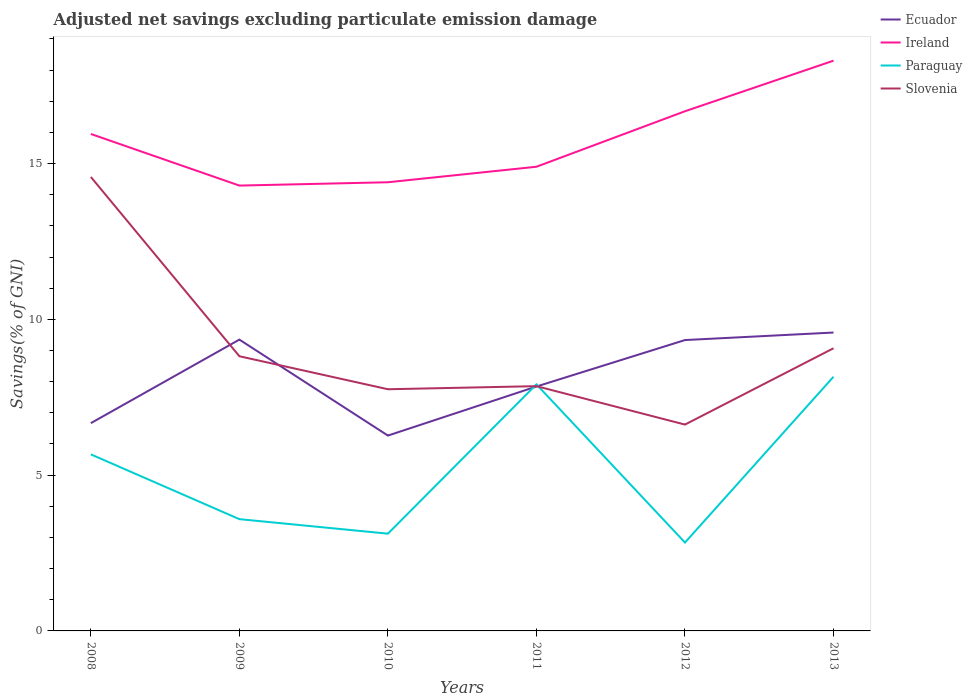How many different coloured lines are there?
Give a very brief answer. 4. Does the line corresponding to Slovenia intersect with the line corresponding to Ireland?
Make the answer very short. No. Is the number of lines equal to the number of legend labels?
Provide a succinct answer. Yes. Across all years, what is the maximum adjusted net savings in Slovenia?
Provide a succinct answer. 6.62. In which year was the adjusted net savings in Slovenia maximum?
Your response must be concise. 2012. What is the total adjusted net savings in Paraguay in the graph?
Make the answer very short. -2.25. What is the difference between the highest and the second highest adjusted net savings in Paraguay?
Your response must be concise. 5.32. Is the adjusted net savings in Ireland strictly greater than the adjusted net savings in Ecuador over the years?
Provide a succinct answer. No. How many lines are there?
Ensure brevity in your answer.  4. Are the values on the major ticks of Y-axis written in scientific E-notation?
Your response must be concise. No. Does the graph contain any zero values?
Ensure brevity in your answer.  No. Does the graph contain grids?
Provide a succinct answer. No. What is the title of the graph?
Ensure brevity in your answer.  Adjusted net savings excluding particulate emission damage. What is the label or title of the Y-axis?
Ensure brevity in your answer.  Savings(% of GNI). What is the Savings(% of GNI) in Ecuador in 2008?
Provide a succinct answer. 6.67. What is the Savings(% of GNI) in Ireland in 2008?
Make the answer very short. 15.95. What is the Savings(% of GNI) of Paraguay in 2008?
Offer a terse response. 5.67. What is the Savings(% of GNI) of Slovenia in 2008?
Make the answer very short. 14.57. What is the Savings(% of GNI) of Ecuador in 2009?
Ensure brevity in your answer.  9.35. What is the Savings(% of GNI) of Ireland in 2009?
Give a very brief answer. 14.29. What is the Savings(% of GNI) in Paraguay in 2009?
Your answer should be compact. 3.59. What is the Savings(% of GNI) of Slovenia in 2009?
Your answer should be very brief. 8.82. What is the Savings(% of GNI) in Ecuador in 2010?
Offer a very short reply. 6.27. What is the Savings(% of GNI) of Ireland in 2010?
Your answer should be very brief. 14.4. What is the Savings(% of GNI) of Paraguay in 2010?
Offer a terse response. 3.12. What is the Savings(% of GNI) in Slovenia in 2010?
Provide a succinct answer. 7.76. What is the Savings(% of GNI) of Ecuador in 2011?
Keep it short and to the point. 7.84. What is the Savings(% of GNI) of Ireland in 2011?
Your answer should be compact. 14.9. What is the Savings(% of GNI) in Paraguay in 2011?
Ensure brevity in your answer.  7.91. What is the Savings(% of GNI) in Slovenia in 2011?
Keep it short and to the point. 7.86. What is the Savings(% of GNI) in Ecuador in 2012?
Offer a terse response. 9.34. What is the Savings(% of GNI) in Ireland in 2012?
Your response must be concise. 16.68. What is the Savings(% of GNI) of Paraguay in 2012?
Your answer should be very brief. 2.84. What is the Savings(% of GNI) in Slovenia in 2012?
Make the answer very short. 6.62. What is the Savings(% of GNI) in Ecuador in 2013?
Give a very brief answer. 9.58. What is the Savings(% of GNI) in Ireland in 2013?
Offer a terse response. 18.3. What is the Savings(% of GNI) of Paraguay in 2013?
Your response must be concise. 8.16. What is the Savings(% of GNI) of Slovenia in 2013?
Your answer should be very brief. 9.07. Across all years, what is the maximum Savings(% of GNI) in Ecuador?
Provide a short and direct response. 9.58. Across all years, what is the maximum Savings(% of GNI) of Ireland?
Your response must be concise. 18.3. Across all years, what is the maximum Savings(% of GNI) in Paraguay?
Provide a short and direct response. 8.16. Across all years, what is the maximum Savings(% of GNI) of Slovenia?
Make the answer very short. 14.57. Across all years, what is the minimum Savings(% of GNI) of Ecuador?
Offer a terse response. 6.27. Across all years, what is the minimum Savings(% of GNI) of Ireland?
Keep it short and to the point. 14.29. Across all years, what is the minimum Savings(% of GNI) of Paraguay?
Your response must be concise. 2.84. Across all years, what is the minimum Savings(% of GNI) of Slovenia?
Provide a succinct answer. 6.62. What is the total Savings(% of GNI) in Ecuador in the graph?
Offer a terse response. 49.05. What is the total Savings(% of GNI) of Ireland in the graph?
Keep it short and to the point. 94.53. What is the total Savings(% of GNI) of Paraguay in the graph?
Offer a terse response. 31.29. What is the total Savings(% of GNI) of Slovenia in the graph?
Provide a short and direct response. 54.7. What is the difference between the Savings(% of GNI) of Ecuador in 2008 and that in 2009?
Offer a very short reply. -2.68. What is the difference between the Savings(% of GNI) in Ireland in 2008 and that in 2009?
Keep it short and to the point. 1.66. What is the difference between the Savings(% of GNI) of Paraguay in 2008 and that in 2009?
Keep it short and to the point. 2.08. What is the difference between the Savings(% of GNI) in Slovenia in 2008 and that in 2009?
Provide a short and direct response. 5.75. What is the difference between the Savings(% of GNI) in Ecuador in 2008 and that in 2010?
Ensure brevity in your answer.  0.4. What is the difference between the Savings(% of GNI) in Ireland in 2008 and that in 2010?
Provide a succinct answer. 1.55. What is the difference between the Savings(% of GNI) of Paraguay in 2008 and that in 2010?
Your answer should be compact. 2.55. What is the difference between the Savings(% of GNI) in Slovenia in 2008 and that in 2010?
Ensure brevity in your answer.  6.81. What is the difference between the Savings(% of GNI) in Ecuador in 2008 and that in 2011?
Your answer should be very brief. -1.18. What is the difference between the Savings(% of GNI) in Ireland in 2008 and that in 2011?
Offer a very short reply. 1.05. What is the difference between the Savings(% of GNI) of Paraguay in 2008 and that in 2011?
Your answer should be compact. -2.25. What is the difference between the Savings(% of GNI) of Slovenia in 2008 and that in 2011?
Give a very brief answer. 6.71. What is the difference between the Savings(% of GNI) of Ecuador in 2008 and that in 2012?
Offer a terse response. -2.67. What is the difference between the Savings(% of GNI) in Ireland in 2008 and that in 2012?
Your answer should be very brief. -0.73. What is the difference between the Savings(% of GNI) of Paraguay in 2008 and that in 2012?
Your answer should be very brief. 2.83. What is the difference between the Savings(% of GNI) in Slovenia in 2008 and that in 2012?
Offer a very short reply. 7.95. What is the difference between the Savings(% of GNI) in Ecuador in 2008 and that in 2013?
Provide a succinct answer. -2.91. What is the difference between the Savings(% of GNI) in Ireland in 2008 and that in 2013?
Your answer should be compact. -2.35. What is the difference between the Savings(% of GNI) in Paraguay in 2008 and that in 2013?
Ensure brevity in your answer.  -2.49. What is the difference between the Savings(% of GNI) of Slovenia in 2008 and that in 2013?
Your response must be concise. 5.5. What is the difference between the Savings(% of GNI) of Ecuador in 2009 and that in 2010?
Give a very brief answer. 3.08. What is the difference between the Savings(% of GNI) in Ireland in 2009 and that in 2010?
Your answer should be compact. -0.11. What is the difference between the Savings(% of GNI) of Paraguay in 2009 and that in 2010?
Give a very brief answer. 0.47. What is the difference between the Savings(% of GNI) in Slovenia in 2009 and that in 2010?
Ensure brevity in your answer.  1.06. What is the difference between the Savings(% of GNI) of Ecuador in 2009 and that in 2011?
Offer a terse response. 1.51. What is the difference between the Savings(% of GNI) of Ireland in 2009 and that in 2011?
Ensure brevity in your answer.  -0.6. What is the difference between the Savings(% of GNI) of Paraguay in 2009 and that in 2011?
Make the answer very short. -4.33. What is the difference between the Savings(% of GNI) in Slovenia in 2009 and that in 2011?
Offer a terse response. 0.96. What is the difference between the Savings(% of GNI) of Ecuador in 2009 and that in 2012?
Offer a very short reply. 0.01. What is the difference between the Savings(% of GNI) of Ireland in 2009 and that in 2012?
Your answer should be compact. -2.39. What is the difference between the Savings(% of GNI) in Paraguay in 2009 and that in 2012?
Your answer should be compact. 0.75. What is the difference between the Savings(% of GNI) of Slovenia in 2009 and that in 2012?
Your answer should be compact. 2.19. What is the difference between the Savings(% of GNI) in Ecuador in 2009 and that in 2013?
Your response must be concise. -0.23. What is the difference between the Savings(% of GNI) of Ireland in 2009 and that in 2013?
Give a very brief answer. -4.01. What is the difference between the Savings(% of GNI) of Paraguay in 2009 and that in 2013?
Your response must be concise. -4.57. What is the difference between the Savings(% of GNI) of Slovenia in 2009 and that in 2013?
Offer a terse response. -0.26. What is the difference between the Savings(% of GNI) in Ecuador in 2010 and that in 2011?
Provide a short and direct response. -1.57. What is the difference between the Savings(% of GNI) of Ireland in 2010 and that in 2011?
Offer a very short reply. -0.5. What is the difference between the Savings(% of GNI) of Paraguay in 2010 and that in 2011?
Provide a short and direct response. -4.79. What is the difference between the Savings(% of GNI) of Slovenia in 2010 and that in 2011?
Provide a short and direct response. -0.1. What is the difference between the Savings(% of GNI) in Ecuador in 2010 and that in 2012?
Provide a succinct answer. -3.07. What is the difference between the Savings(% of GNI) of Ireland in 2010 and that in 2012?
Offer a terse response. -2.28. What is the difference between the Savings(% of GNI) of Paraguay in 2010 and that in 2012?
Give a very brief answer. 0.28. What is the difference between the Savings(% of GNI) in Slovenia in 2010 and that in 2012?
Make the answer very short. 1.13. What is the difference between the Savings(% of GNI) of Ecuador in 2010 and that in 2013?
Offer a terse response. -3.31. What is the difference between the Savings(% of GNI) of Ireland in 2010 and that in 2013?
Your answer should be very brief. -3.9. What is the difference between the Savings(% of GNI) of Paraguay in 2010 and that in 2013?
Ensure brevity in your answer.  -5.04. What is the difference between the Savings(% of GNI) of Slovenia in 2010 and that in 2013?
Make the answer very short. -1.32. What is the difference between the Savings(% of GNI) of Ecuador in 2011 and that in 2012?
Give a very brief answer. -1.49. What is the difference between the Savings(% of GNI) in Ireland in 2011 and that in 2012?
Provide a short and direct response. -1.78. What is the difference between the Savings(% of GNI) of Paraguay in 2011 and that in 2012?
Give a very brief answer. 5.08. What is the difference between the Savings(% of GNI) in Slovenia in 2011 and that in 2012?
Ensure brevity in your answer.  1.23. What is the difference between the Savings(% of GNI) of Ecuador in 2011 and that in 2013?
Ensure brevity in your answer.  -1.73. What is the difference between the Savings(% of GNI) in Ireland in 2011 and that in 2013?
Provide a succinct answer. -3.4. What is the difference between the Savings(% of GNI) in Paraguay in 2011 and that in 2013?
Your answer should be compact. -0.24. What is the difference between the Savings(% of GNI) in Slovenia in 2011 and that in 2013?
Provide a succinct answer. -1.22. What is the difference between the Savings(% of GNI) in Ecuador in 2012 and that in 2013?
Offer a terse response. -0.24. What is the difference between the Savings(% of GNI) of Ireland in 2012 and that in 2013?
Your answer should be compact. -1.62. What is the difference between the Savings(% of GNI) in Paraguay in 2012 and that in 2013?
Offer a terse response. -5.32. What is the difference between the Savings(% of GNI) of Slovenia in 2012 and that in 2013?
Provide a short and direct response. -2.45. What is the difference between the Savings(% of GNI) in Ecuador in 2008 and the Savings(% of GNI) in Ireland in 2009?
Keep it short and to the point. -7.63. What is the difference between the Savings(% of GNI) of Ecuador in 2008 and the Savings(% of GNI) of Paraguay in 2009?
Give a very brief answer. 3.08. What is the difference between the Savings(% of GNI) in Ecuador in 2008 and the Savings(% of GNI) in Slovenia in 2009?
Ensure brevity in your answer.  -2.15. What is the difference between the Savings(% of GNI) of Ireland in 2008 and the Savings(% of GNI) of Paraguay in 2009?
Ensure brevity in your answer.  12.36. What is the difference between the Savings(% of GNI) in Ireland in 2008 and the Savings(% of GNI) in Slovenia in 2009?
Your answer should be compact. 7.13. What is the difference between the Savings(% of GNI) of Paraguay in 2008 and the Savings(% of GNI) of Slovenia in 2009?
Your answer should be very brief. -3.15. What is the difference between the Savings(% of GNI) in Ecuador in 2008 and the Savings(% of GNI) in Ireland in 2010?
Ensure brevity in your answer.  -7.73. What is the difference between the Savings(% of GNI) of Ecuador in 2008 and the Savings(% of GNI) of Paraguay in 2010?
Your response must be concise. 3.55. What is the difference between the Savings(% of GNI) of Ecuador in 2008 and the Savings(% of GNI) of Slovenia in 2010?
Provide a short and direct response. -1.09. What is the difference between the Savings(% of GNI) in Ireland in 2008 and the Savings(% of GNI) in Paraguay in 2010?
Your response must be concise. 12.83. What is the difference between the Savings(% of GNI) of Ireland in 2008 and the Savings(% of GNI) of Slovenia in 2010?
Your response must be concise. 8.19. What is the difference between the Savings(% of GNI) in Paraguay in 2008 and the Savings(% of GNI) in Slovenia in 2010?
Ensure brevity in your answer.  -2.09. What is the difference between the Savings(% of GNI) in Ecuador in 2008 and the Savings(% of GNI) in Ireland in 2011?
Your answer should be compact. -8.23. What is the difference between the Savings(% of GNI) in Ecuador in 2008 and the Savings(% of GNI) in Paraguay in 2011?
Offer a terse response. -1.25. What is the difference between the Savings(% of GNI) of Ecuador in 2008 and the Savings(% of GNI) of Slovenia in 2011?
Offer a very short reply. -1.19. What is the difference between the Savings(% of GNI) in Ireland in 2008 and the Savings(% of GNI) in Paraguay in 2011?
Ensure brevity in your answer.  8.04. What is the difference between the Savings(% of GNI) in Ireland in 2008 and the Savings(% of GNI) in Slovenia in 2011?
Keep it short and to the point. 8.09. What is the difference between the Savings(% of GNI) of Paraguay in 2008 and the Savings(% of GNI) of Slovenia in 2011?
Your answer should be compact. -2.19. What is the difference between the Savings(% of GNI) of Ecuador in 2008 and the Savings(% of GNI) of Ireland in 2012?
Provide a succinct answer. -10.01. What is the difference between the Savings(% of GNI) in Ecuador in 2008 and the Savings(% of GNI) in Paraguay in 2012?
Give a very brief answer. 3.83. What is the difference between the Savings(% of GNI) in Ecuador in 2008 and the Savings(% of GNI) in Slovenia in 2012?
Your response must be concise. 0.05. What is the difference between the Savings(% of GNI) of Ireland in 2008 and the Savings(% of GNI) of Paraguay in 2012?
Your answer should be very brief. 13.11. What is the difference between the Savings(% of GNI) of Ireland in 2008 and the Savings(% of GNI) of Slovenia in 2012?
Offer a terse response. 9.33. What is the difference between the Savings(% of GNI) in Paraguay in 2008 and the Savings(% of GNI) in Slovenia in 2012?
Offer a terse response. -0.96. What is the difference between the Savings(% of GNI) in Ecuador in 2008 and the Savings(% of GNI) in Ireland in 2013?
Make the answer very short. -11.63. What is the difference between the Savings(% of GNI) of Ecuador in 2008 and the Savings(% of GNI) of Paraguay in 2013?
Offer a very short reply. -1.49. What is the difference between the Savings(% of GNI) in Ecuador in 2008 and the Savings(% of GNI) in Slovenia in 2013?
Make the answer very short. -2.4. What is the difference between the Savings(% of GNI) of Ireland in 2008 and the Savings(% of GNI) of Paraguay in 2013?
Your answer should be very brief. 7.79. What is the difference between the Savings(% of GNI) in Ireland in 2008 and the Savings(% of GNI) in Slovenia in 2013?
Make the answer very short. 6.88. What is the difference between the Savings(% of GNI) in Paraguay in 2008 and the Savings(% of GNI) in Slovenia in 2013?
Provide a short and direct response. -3.41. What is the difference between the Savings(% of GNI) of Ecuador in 2009 and the Savings(% of GNI) of Ireland in 2010?
Provide a succinct answer. -5.05. What is the difference between the Savings(% of GNI) in Ecuador in 2009 and the Savings(% of GNI) in Paraguay in 2010?
Ensure brevity in your answer.  6.23. What is the difference between the Savings(% of GNI) of Ecuador in 2009 and the Savings(% of GNI) of Slovenia in 2010?
Offer a terse response. 1.59. What is the difference between the Savings(% of GNI) of Ireland in 2009 and the Savings(% of GNI) of Paraguay in 2010?
Offer a terse response. 11.17. What is the difference between the Savings(% of GNI) of Ireland in 2009 and the Savings(% of GNI) of Slovenia in 2010?
Keep it short and to the point. 6.54. What is the difference between the Savings(% of GNI) of Paraguay in 2009 and the Savings(% of GNI) of Slovenia in 2010?
Offer a very short reply. -4.17. What is the difference between the Savings(% of GNI) of Ecuador in 2009 and the Savings(% of GNI) of Ireland in 2011?
Make the answer very short. -5.55. What is the difference between the Savings(% of GNI) in Ecuador in 2009 and the Savings(% of GNI) in Paraguay in 2011?
Your response must be concise. 1.44. What is the difference between the Savings(% of GNI) of Ecuador in 2009 and the Savings(% of GNI) of Slovenia in 2011?
Ensure brevity in your answer.  1.49. What is the difference between the Savings(% of GNI) of Ireland in 2009 and the Savings(% of GNI) of Paraguay in 2011?
Offer a very short reply. 6.38. What is the difference between the Savings(% of GNI) in Ireland in 2009 and the Savings(% of GNI) in Slovenia in 2011?
Your answer should be very brief. 6.44. What is the difference between the Savings(% of GNI) of Paraguay in 2009 and the Savings(% of GNI) of Slovenia in 2011?
Ensure brevity in your answer.  -4.27. What is the difference between the Savings(% of GNI) in Ecuador in 2009 and the Savings(% of GNI) in Ireland in 2012?
Your response must be concise. -7.33. What is the difference between the Savings(% of GNI) in Ecuador in 2009 and the Savings(% of GNI) in Paraguay in 2012?
Provide a succinct answer. 6.51. What is the difference between the Savings(% of GNI) of Ecuador in 2009 and the Savings(% of GNI) of Slovenia in 2012?
Keep it short and to the point. 2.73. What is the difference between the Savings(% of GNI) in Ireland in 2009 and the Savings(% of GNI) in Paraguay in 2012?
Keep it short and to the point. 11.46. What is the difference between the Savings(% of GNI) of Ireland in 2009 and the Savings(% of GNI) of Slovenia in 2012?
Keep it short and to the point. 7.67. What is the difference between the Savings(% of GNI) in Paraguay in 2009 and the Savings(% of GNI) in Slovenia in 2012?
Keep it short and to the point. -3.04. What is the difference between the Savings(% of GNI) of Ecuador in 2009 and the Savings(% of GNI) of Ireland in 2013?
Keep it short and to the point. -8.95. What is the difference between the Savings(% of GNI) in Ecuador in 2009 and the Savings(% of GNI) in Paraguay in 2013?
Keep it short and to the point. 1.19. What is the difference between the Savings(% of GNI) in Ecuador in 2009 and the Savings(% of GNI) in Slovenia in 2013?
Provide a short and direct response. 0.28. What is the difference between the Savings(% of GNI) in Ireland in 2009 and the Savings(% of GNI) in Paraguay in 2013?
Your response must be concise. 6.14. What is the difference between the Savings(% of GNI) of Ireland in 2009 and the Savings(% of GNI) of Slovenia in 2013?
Your response must be concise. 5.22. What is the difference between the Savings(% of GNI) in Paraguay in 2009 and the Savings(% of GNI) in Slovenia in 2013?
Keep it short and to the point. -5.49. What is the difference between the Savings(% of GNI) of Ecuador in 2010 and the Savings(% of GNI) of Ireland in 2011?
Your answer should be very brief. -8.63. What is the difference between the Savings(% of GNI) in Ecuador in 2010 and the Savings(% of GNI) in Paraguay in 2011?
Provide a short and direct response. -1.64. What is the difference between the Savings(% of GNI) of Ecuador in 2010 and the Savings(% of GNI) of Slovenia in 2011?
Your response must be concise. -1.59. What is the difference between the Savings(% of GNI) in Ireland in 2010 and the Savings(% of GNI) in Paraguay in 2011?
Give a very brief answer. 6.49. What is the difference between the Savings(% of GNI) of Ireland in 2010 and the Savings(% of GNI) of Slovenia in 2011?
Offer a very short reply. 6.54. What is the difference between the Savings(% of GNI) in Paraguay in 2010 and the Savings(% of GNI) in Slovenia in 2011?
Provide a succinct answer. -4.74. What is the difference between the Savings(% of GNI) in Ecuador in 2010 and the Savings(% of GNI) in Ireland in 2012?
Offer a very short reply. -10.41. What is the difference between the Savings(% of GNI) in Ecuador in 2010 and the Savings(% of GNI) in Paraguay in 2012?
Your answer should be very brief. 3.43. What is the difference between the Savings(% of GNI) of Ecuador in 2010 and the Savings(% of GNI) of Slovenia in 2012?
Provide a short and direct response. -0.35. What is the difference between the Savings(% of GNI) in Ireland in 2010 and the Savings(% of GNI) in Paraguay in 2012?
Provide a succinct answer. 11.56. What is the difference between the Savings(% of GNI) in Ireland in 2010 and the Savings(% of GNI) in Slovenia in 2012?
Provide a succinct answer. 7.78. What is the difference between the Savings(% of GNI) of Paraguay in 2010 and the Savings(% of GNI) of Slovenia in 2012?
Give a very brief answer. -3.5. What is the difference between the Savings(% of GNI) of Ecuador in 2010 and the Savings(% of GNI) of Ireland in 2013?
Offer a terse response. -12.03. What is the difference between the Savings(% of GNI) of Ecuador in 2010 and the Savings(% of GNI) of Paraguay in 2013?
Keep it short and to the point. -1.89. What is the difference between the Savings(% of GNI) of Ecuador in 2010 and the Savings(% of GNI) of Slovenia in 2013?
Give a very brief answer. -2.8. What is the difference between the Savings(% of GNI) in Ireland in 2010 and the Savings(% of GNI) in Paraguay in 2013?
Your answer should be very brief. 6.24. What is the difference between the Savings(% of GNI) in Ireland in 2010 and the Savings(% of GNI) in Slovenia in 2013?
Your response must be concise. 5.33. What is the difference between the Savings(% of GNI) of Paraguay in 2010 and the Savings(% of GNI) of Slovenia in 2013?
Your response must be concise. -5.95. What is the difference between the Savings(% of GNI) in Ecuador in 2011 and the Savings(% of GNI) in Ireland in 2012?
Your response must be concise. -8.83. What is the difference between the Savings(% of GNI) in Ecuador in 2011 and the Savings(% of GNI) in Paraguay in 2012?
Provide a succinct answer. 5.01. What is the difference between the Savings(% of GNI) in Ecuador in 2011 and the Savings(% of GNI) in Slovenia in 2012?
Your answer should be compact. 1.22. What is the difference between the Savings(% of GNI) of Ireland in 2011 and the Savings(% of GNI) of Paraguay in 2012?
Keep it short and to the point. 12.06. What is the difference between the Savings(% of GNI) of Ireland in 2011 and the Savings(% of GNI) of Slovenia in 2012?
Your answer should be compact. 8.28. What is the difference between the Savings(% of GNI) in Paraguay in 2011 and the Savings(% of GNI) in Slovenia in 2012?
Ensure brevity in your answer.  1.29. What is the difference between the Savings(% of GNI) of Ecuador in 2011 and the Savings(% of GNI) of Ireland in 2013?
Make the answer very short. -10.46. What is the difference between the Savings(% of GNI) in Ecuador in 2011 and the Savings(% of GNI) in Paraguay in 2013?
Provide a succinct answer. -0.31. What is the difference between the Savings(% of GNI) of Ecuador in 2011 and the Savings(% of GNI) of Slovenia in 2013?
Keep it short and to the point. -1.23. What is the difference between the Savings(% of GNI) in Ireland in 2011 and the Savings(% of GNI) in Paraguay in 2013?
Your response must be concise. 6.74. What is the difference between the Savings(% of GNI) of Ireland in 2011 and the Savings(% of GNI) of Slovenia in 2013?
Your answer should be compact. 5.83. What is the difference between the Savings(% of GNI) of Paraguay in 2011 and the Savings(% of GNI) of Slovenia in 2013?
Provide a short and direct response. -1.16. What is the difference between the Savings(% of GNI) in Ecuador in 2012 and the Savings(% of GNI) in Ireland in 2013?
Your answer should be compact. -8.97. What is the difference between the Savings(% of GNI) of Ecuador in 2012 and the Savings(% of GNI) of Paraguay in 2013?
Offer a terse response. 1.18. What is the difference between the Savings(% of GNI) of Ecuador in 2012 and the Savings(% of GNI) of Slovenia in 2013?
Keep it short and to the point. 0.26. What is the difference between the Savings(% of GNI) in Ireland in 2012 and the Savings(% of GNI) in Paraguay in 2013?
Offer a very short reply. 8.52. What is the difference between the Savings(% of GNI) of Ireland in 2012 and the Savings(% of GNI) of Slovenia in 2013?
Make the answer very short. 7.61. What is the difference between the Savings(% of GNI) of Paraguay in 2012 and the Savings(% of GNI) of Slovenia in 2013?
Provide a succinct answer. -6.24. What is the average Savings(% of GNI) of Ecuador per year?
Provide a succinct answer. 8.17. What is the average Savings(% of GNI) of Ireland per year?
Make the answer very short. 15.75. What is the average Savings(% of GNI) of Paraguay per year?
Provide a short and direct response. 5.21. What is the average Savings(% of GNI) of Slovenia per year?
Give a very brief answer. 9.12. In the year 2008, what is the difference between the Savings(% of GNI) of Ecuador and Savings(% of GNI) of Ireland?
Provide a short and direct response. -9.28. In the year 2008, what is the difference between the Savings(% of GNI) of Ecuador and Savings(% of GNI) of Paraguay?
Keep it short and to the point. 1. In the year 2008, what is the difference between the Savings(% of GNI) in Ecuador and Savings(% of GNI) in Slovenia?
Keep it short and to the point. -7.9. In the year 2008, what is the difference between the Savings(% of GNI) in Ireland and Savings(% of GNI) in Paraguay?
Keep it short and to the point. 10.28. In the year 2008, what is the difference between the Savings(% of GNI) in Ireland and Savings(% of GNI) in Slovenia?
Offer a very short reply. 1.38. In the year 2008, what is the difference between the Savings(% of GNI) in Paraguay and Savings(% of GNI) in Slovenia?
Provide a succinct answer. -8.9. In the year 2009, what is the difference between the Savings(% of GNI) in Ecuador and Savings(% of GNI) in Ireland?
Offer a very short reply. -4.94. In the year 2009, what is the difference between the Savings(% of GNI) of Ecuador and Savings(% of GNI) of Paraguay?
Offer a terse response. 5.76. In the year 2009, what is the difference between the Savings(% of GNI) in Ecuador and Savings(% of GNI) in Slovenia?
Offer a terse response. 0.53. In the year 2009, what is the difference between the Savings(% of GNI) in Ireland and Savings(% of GNI) in Paraguay?
Your answer should be very brief. 10.71. In the year 2009, what is the difference between the Savings(% of GNI) in Ireland and Savings(% of GNI) in Slovenia?
Keep it short and to the point. 5.48. In the year 2009, what is the difference between the Savings(% of GNI) in Paraguay and Savings(% of GNI) in Slovenia?
Provide a short and direct response. -5.23. In the year 2010, what is the difference between the Savings(% of GNI) in Ecuador and Savings(% of GNI) in Ireland?
Your answer should be compact. -8.13. In the year 2010, what is the difference between the Savings(% of GNI) in Ecuador and Savings(% of GNI) in Paraguay?
Offer a very short reply. 3.15. In the year 2010, what is the difference between the Savings(% of GNI) in Ecuador and Savings(% of GNI) in Slovenia?
Your answer should be compact. -1.49. In the year 2010, what is the difference between the Savings(% of GNI) of Ireland and Savings(% of GNI) of Paraguay?
Your response must be concise. 11.28. In the year 2010, what is the difference between the Savings(% of GNI) in Ireland and Savings(% of GNI) in Slovenia?
Provide a succinct answer. 6.64. In the year 2010, what is the difference between the Savings(% of GNI) of Paraguay and Savings(% of GNI) of Slovenia?
Provide a succinct answer. -4.64. In the year 2011, what is the difference between the Savings(% of GNI) of Ecuador and Savings(% of GNI) of Ireland?
Your answer should be compact. -7.05. In the year 2011, what is the difference between the Savings(% of GNI) of Ecuador and Savings(% of GNI) of Paraguay?
Your answer should be very brief. -0.07. In the year 2011, what is the difference between the Savings(% of GNI) of Ecuador and Savings(% of GNI) of Slovenia?
Offer a terse response. -0.01. In the year 2011, what is the difference between the Savings(% of GNI) in Ireland and Savings(% of GNI) in Paraguay?
Provide a short and direct response. 6.98. In the year 2011, what is the difference between the Savings(% of GNI) in Ireland and Savings(% of GNI) in Slovenia?
Provide a short and direct response. 7.04. In the year 2011, what is the difference between the Savings(% of GNI) of Paraguay and Savings(% of GNI) of Slovenia?
Your response must be concise. 0.06. In the year 2012, what is the difference between the Savings(% of GNI) of Ecuador and Savings(% of GNI) of Ireland?
Offer a very short reply. -7.34. In the year 2012, what is the difference between the Savings(% of GNI) of Ecuador and Savings(% of GNI) of Paraguay?
Your response must be concise. 6.5. In the year 2012, what is the difference between the Savings(% of GNI) in Ecuador and Savings(% of GNI) in Slovenia?
Offer a terse response. 2.71. In the year 2012, what is the difference between the Savings(% of GNI) of Ireland and Savings(% of GNI) of Paraguay?
Keep it short and to the point. 13.84. In the year 2012, what is the difference between the Savings(% of GNI) of Ireland and Savings(% of GNI) of Slovenia?
Your response must be concise. 10.06. In the year 2012, what is the difference between the Savings(% of GNI) of Paraguay and Savings(% of GNI) of Slovenia?
Provide a short and direct response. -3.79. In the year 2013, what is the difference between the Savings(% of GNI) of Ecuador and Savings(% of GNI) of Ireland?
Offer a very short reply. -8.73. In the year 2013, what is the difference between the Savings(% of GNI) in Ecuador and Savings(% of GNI) in Paraguay?
Keep it short and to the point. 1.42. In the year 2013, what is the difference between the Savings(% of GNI) of Ecuador and Savings(% of GNI) of Slovenia?
Make the answer very short. 0.5. In the year 2013, what is the difference between the Savings(% of GNI) in Ireland and Savings(% of GNI) in Paraguay?
Ensure brevity in your answer.  10.14. In the year 2013, what is the difference between the Savings(% of GNI) of Ireland and Savings(% of GNI) of Slovenia?
Give a very brief answer. 9.23. In the year 2013, what is the difference between the Savings(% of GNI) of Paraguay and Savings(% of GNI) of Slovenia?
Keep it short and to the point. -0.91. What is the ratio of the Savings(% of GNI) of Ecuador in 2008 to that in 2009?
Your answer should be compact. 0.71. What is the ratio of the Savings(% of GNI) in Ireland in 2008 to that in 2009?
Provide a succinct answer. 1.12. What is the ratio of the Savings(% of GNI) in Paraguay in 2008 to that in 2009?
Your answer should be very brief. 1.58. What is the ratio of the Savings(% of GNI) of Slovenia in 2008 to that in 2009?
Ensure brevity in your answer.  1.65. What is the ratio of the Savings(% of GNI) in Ecuador in 2008 to that in 2010?
Your response must be concise. 1.06. What is the ratio of the Savings(% of GNI) of Ireland in 2008 to that in 2010?
Ensure brevity in your answer.  1.11. What is the ratio of the Savings(% of GNI) in Paraguay in 2008 to that in 2010?
Provide a short and direct response. 1.82. What is the ratio of the Savings(% of GNI) in Slovenia in 2008 to that in 2010?
Provide a short and direct response. 1.88. What is the ratio of the Savings(% of GNI) in Ecuador in 2008 to that in 2011?
Offer a terse response. 0.85. What is the ratio of the Savings(% of GNI) in Ireland in 2008 to that in 2011?
Your response must be concise. 1.07. What is the ratio of the Savings(% of GNI) in Paraguay in 2008 to that in 2011?
Offer a terse response. 0.72. What is the ratio of the Savings(% of GNI) of Slovenia in 2008 to that in 2011?
Your response must be concise. 1.85. What is the ratio of the Savings(% of GNI) in Ecuador in 2008 to that in 2012?
Your response must be concise. 0.71. What is the ratio of the Savings(% of GNI) in Ireland in 2008 to that in 2012?
Provide a succinct answer. 0.96. What is the ratio of the Savings(% of GNI) in Paraguay in 2008 to that in 2012?
Ensure brevity in your answer.  2. What is the ratio of the Savings(% of GNI) in Ecuador in 2008 to that in 2013?
Your response must be concise. 0.7. What is the ratio of the Savings(% of GNI) of Ireland in 2008 to that in 2013?
Make the answer very short. 0.87. What is the ratio of the Savings(% of GNI) in Paraguay in 2008 to that in 2013?
Keep it short and to the point. 0.69. What is the ratio of the Savings(% of GNI) of Slovenia in 2008 to that in 2013?
Give a very brief answer. 1.61. What is the ratio of the Savings(% of GNI) in Ecuador in 2009 to that in 2010?
Provide a succinct answer. 1.49. What is the ratio of the Savings(% of GNI) of Ireland in 2009 to that in 2010?
Provide a short and direct response. 0.99. What is the ratio of the Savings(% of GNI) of Paraguay in 2009 to that in 2010?
Give a very brief answer. 1.15. What is the ratio of the Savings(% of GNI) of Slovenia in 2009 to that in 2010?
Ensure brevity in your answer.  1.14. What is the ratio of the Savings(% of GNI) in Ecuador in 2009 to that in 2011?
Your answer should be compact. 1.19. What is the ratio of the Savings(% of GNI) in Ireland in 2009 to that in 2011?
Your response must be concise. 0.96. What is the ratio of the Savings(% of GNI) in Paraguay in 2009 to that in 2011?
Your answer should be compact. 0.45. What is the ratio of the Savings(% of GNI) of Slovenia in 2009 to that in 2011?
Ensure brevity in your answer.  1.12. What is the ratio of the Savings(% of GNI) of Ecuador in 2009 to that in 2012?
Keep it short and to the point. 1. What is the ratio of the Savings(% of GNI) in Ireland in 2009 to that in 2012?
Your answer should be very brief. 0.86. What is the ratio of the Savings(% of GNI) of Paraguay in 2009 to that in 2012?
Provide a succinct answer. 1.26. What is the ratio of the Savings(% of GNI) of Slovenia in 2009 to that in 2012?
Provide a succinct answer. 1.33. What is the ratio of the Savings(% of GNI) in Ecuador in 2009 to that in 2013?
Keep it short and to the point. 0.98. What is the ratio of the Savings(% of GNI) in Ireland in 2009 to that in 2013?
Provide a short and direct response. 0.78. What is the ratio of the Savings(% of GNI) of Paraguay in 2009 to that in 2013?
Give a very brief answer. 0.44. What is the ratio of the Savings(% of GNI) in Slovenia in 2009 to that in 2013?
Offer a terse response. 0.97. What is the ratio of the Savings(% of GNI) of Ecuador in 2010 to that in 2011?
Your answer should be compact. 0.8. What is the ratio of the Savings(% of GNI) in Ireland in 2010 to that in 2011?
Your response must be concise. 0.97. What is the ratio of the Savings(% of GNI) in Paraguay in 2010 to that in 2011?
Ensure brevity in your answer.  0.39. What is the ratio of the Savings(% of GNI) in Slovenia in 2010 to that in 2011?
Provide a succinct answer. 0.99. What is the ratio of the Savings(% of GNI) of Ecuador in 2010 to that in 2012?
Make the answer very short. 0.67. What is the ratio of the Savings(% of GNI) in Ireland in 2010 to that in 2012?
Your response must be concise. 0.86. What is the ratio of the Savings(% of GNI) in Paraguay in 2010 to that in 2012?
Make the answer very short. 1.1. What is the ratio of the Savings(% of GNI) in Slovenia in 2010 to that in 2012?
Make the answer very short. 1.17. What is the ratio of the Savings(% of GNI) of Ecuador in 2010 to that in 2013?
Offer a very short reply. 0.65. What is the ratio of the Savings(% of GNI) in Ireland in 2010 to that in 2013?
Offer a very short reply. 0.79. What is the ratio of the Savings(% of GNI) in Paraguay in 2010 to that in 2013?
Offer a terse response. 0.38. What is the ratio of the Savings(% of GNI) in Slovenia in 2010 to that in 2013?
Give a very brief answer. 0.85. What is the ratio of the Savings(% of GNI) in Ecuador in 2011 to that in 2012?
Provide a succinct answer. 0.84. What is the ratio of the Savings(% of GNI) of Ireland in 2011 to that in 2012?
Offer a very short reply. 0.89. What is the ratio of the Savings(% of GNI) of Paraguay in 2011 to that in 2012?
Offer a very short reply. 2.79. What is the ratio of the Savings(% of GNI) in Slovenia in 2011 to that in 2012?
Offer a terse response. 1.19. What is the ratio of the Savings(% of GNI) in Ecuador in 2011 to that in 2013?
Your answer should be very brief. 0.82. What is the ratio of the Savings(% of GNI) in Ireland in 2011 to that in 2013?
Make the answer very short. 0.81. What is the ratio of the Savings(% of GNI) of Paraguay in 2011 to that in 2013?
Your answer should be very brief. 0.97. What is the ratio of the Savings(% of GNI) in Slovenia in 2011 to that in 2013?
Give a very brief answer. 0.87. What is the ratio of the Savings(% of GNI) in Ecuador in 2012 to that in 2013?
Give a very brief answer. 0.97. What is the ratio of the Savings(% of GNI) in Ireland in 2012 to that in 2013?
Ensure brevity in your answer.  0.91. What is the ratio of the Savings(% of GNI) in Paraguay in 2012 to that in 2013?
Keep it short and to the point. 0.35. What is the ratio of the Savings(% of GNI) in Slovenia in 2012 to that in 2013?
Your answer should be very brief. 0.73. What is the difference between the highest and the second highest Savings(% of GNI) of Ecuador?
Offer a very short reply. 0.23. What is the difference between the highest and the second highest Savings(% of GNI) of Ireland?
Provide a short and direct response. 1.62. What is the difference between the highest and the second highest Savings(% of GNI) of Paraguay?
Keep it short and to the point. 0.24. What is the difference between the highest and the second highest Savings(% of GNI) of Slovenia?
Your response must be concise. 5.5. What is the difference between the highest and the lowest Savings(% of GNI) of Ecuador?
Make the answer very short. 3.31. What is the difference between the highest and the lowest Savings(% of GNI) in Ireland?
Offer a very short reply. 4.01. What is the difference between the highest and the lowest Savings(% of GNI) of Paraguay?
Make the answer very short. 5.32. What is the difference between the highest and the lowest Savings(% of GNI) of Slovenia?
Provide a short and direct response. 7.95. 